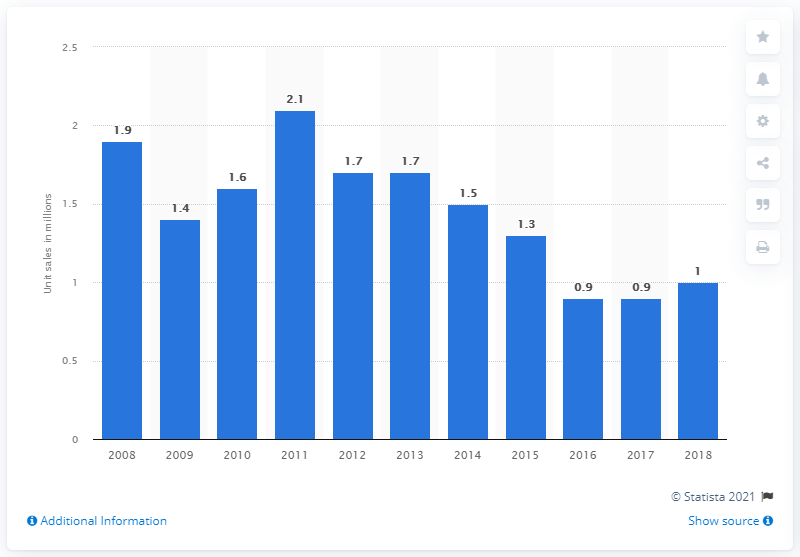Highlight a few significant elements in this photo. In 2011, the number of two-wheelers sold in Manaus' Industrial Pole was 2.1. In the previous year, the number of two-wheeler sales in Manaus' Industrial Pole was 0.9. 